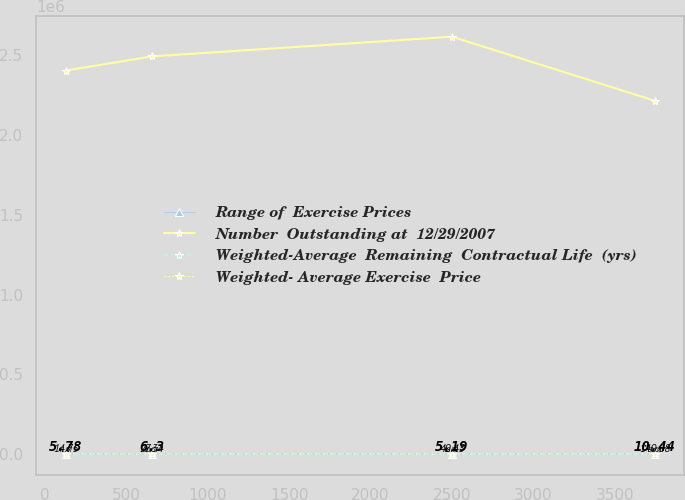Convert chart to OTSL. <chart><loc_0><loc_0><loc_500><loc_500><line_chart><ecel><fcel>Range of  Exercise Prices<fcel>Number  Outstanding at  12/29/2007<fcel>Weighted-Average  Remaining  Contractual Life  (yrs)<fcel>Weighted- Average Exercise  Price<nl><fcel>128.14<fcel>14.75<fcel>2.40463e+06<fcel>5.78<fcel>10.07<nl><fcel>659.32<fcel>27.34<fcel>2.49321e+06<fcel>6.3<fcel>20.57<nl><fcel>2501.2<fcel>40.43<fcel>2.61657e+06<fcel>5.19<fcel>28.52<nl><fcel>3747.91<fcel>140.68<fcel>2.21461e+06<fcel>10.44<fcel>57.68<nl></chart> 